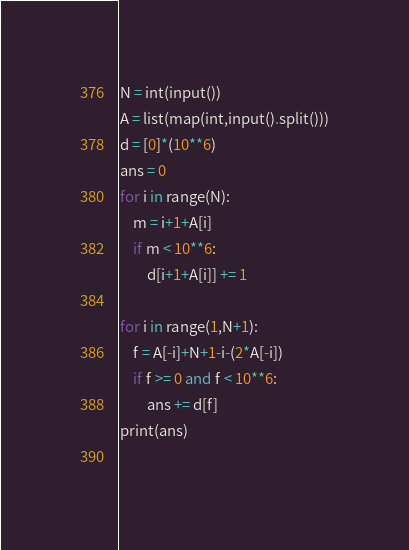<code> <loc_0><loc_0><loc_500><loc_500><_Python_>N = int(input())
A = list(map(int,input().split()))
d = [0]*(10**6)
ans = 0
for i in range(N):
    m = i+1+A[i]
    if m < 10**6:
        d[i+1+A[i]] += 1
    
for i in range(1,N+1):
    f = A[-i]+N+1-i-(2*A[-i])
    if f >= 0 and f < 10**6:
        ans += d[f]
print(ans)
    </code> 